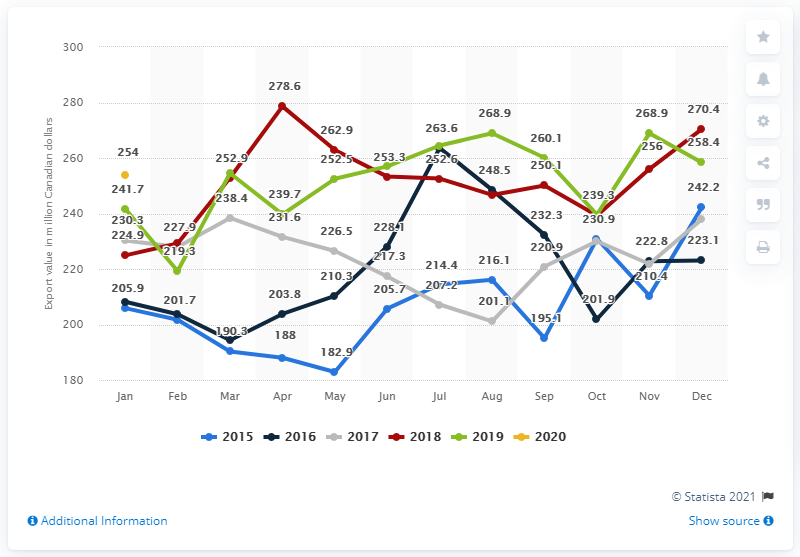Identify some key points in this picture. The export value of animal feed from Canada in January 2020 was approximately 256 million dollars. 